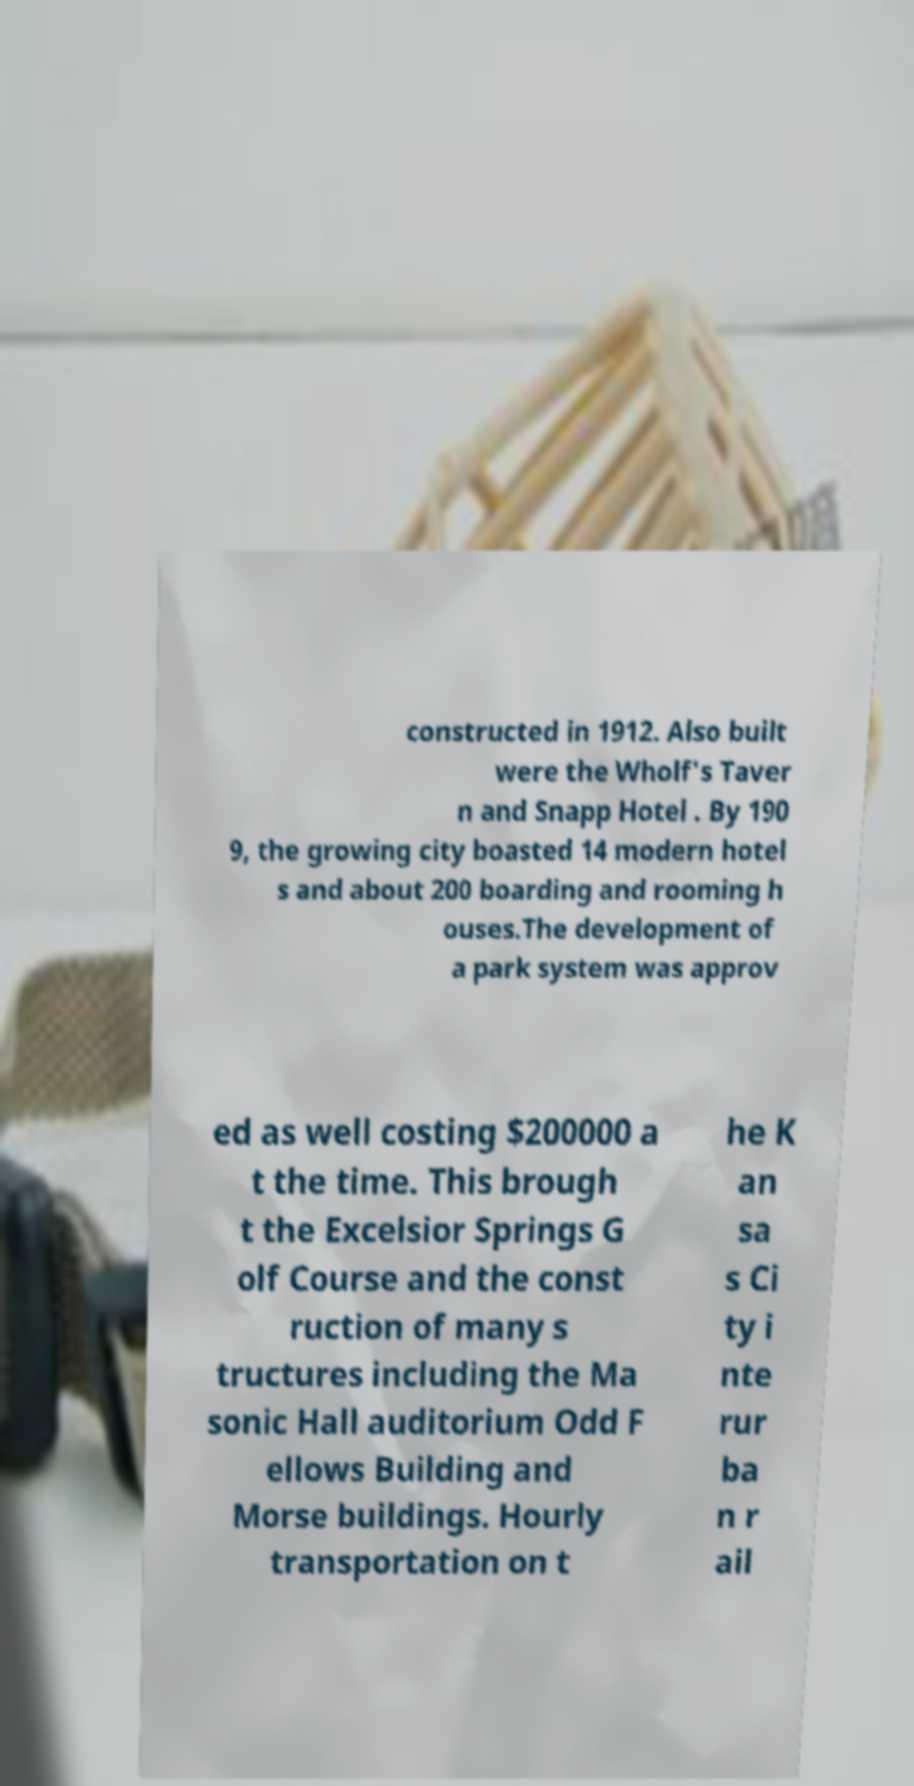There's text embedded in this image that I need extracted. Can you transcribe it verbatim? constructed in 1912. Also built were the Wholf's Taver n and Snapp Hotel . By 190 9, the growing city boasted 14 modern hotel s and about 200 boarding and rooming h ouses.The development of a park system was approv ed as well costing $200000 a t the time. This brough t the Excelsior Springs G olf Course and the const ruction of many s tructures including the Ma sonic Hall auditorium Odd F ellows Building and Morse buildings. Hourly transportation on t he K an sa s Ci ty i nte rur ba n r ail 